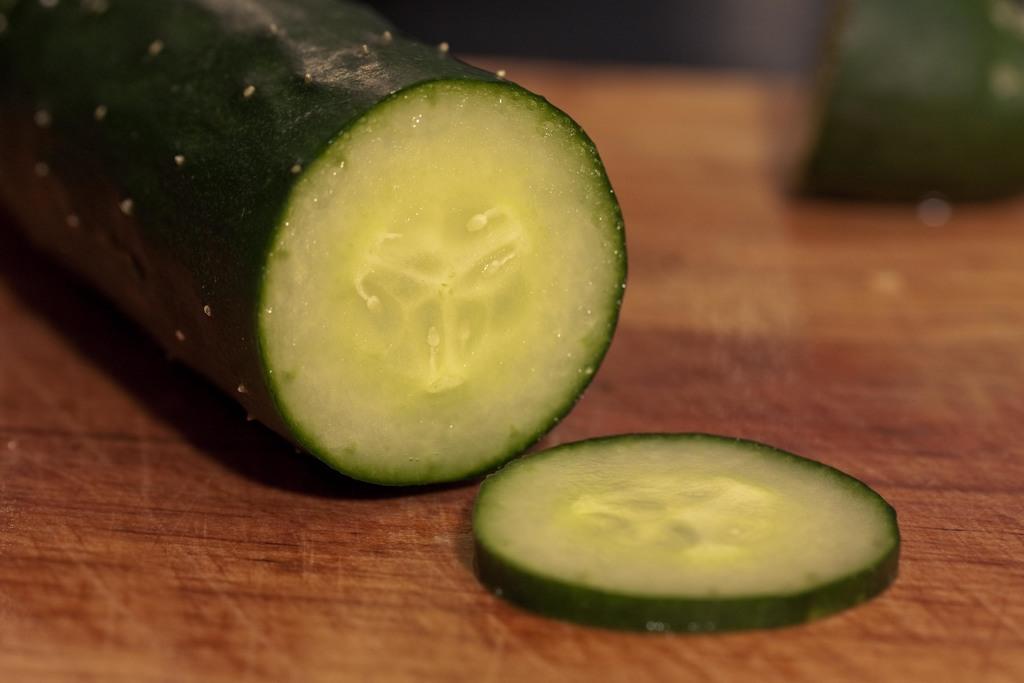How would you summarize this image in a sentence or two? In this image, we can see a cucumber slice and in the background, there are some more cucumbers on the table. 